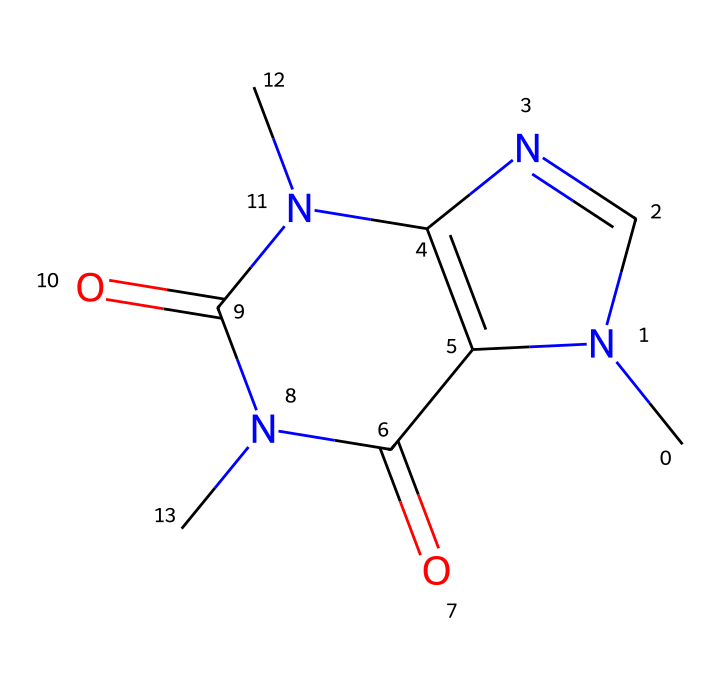What is the molecular formula of caffeine? By analyzing the provided SMILES representation, we can identify the individual atoms present in the chemical structure. The structure contains 8 carbon (C), 10 hydrogen (H), 4 nitrogen (N), and 2 oxygen (O) atoms. Thus, the molecular formula can be compiled as C8H10N4O2.
Answer: C8H10N4O2 How many nitrogen atoms are in caffeine? From the SMILES notation, we can count the number of nitrogen (N) atoms in the structure. The structure shows four distinct nitrogen atoms present.
Answer: 4 What functional groups are present in caffeine? The SMILES representation indicates the presence of carbonyl groups (C=O) and amino groups (N). Caffeine has two carbonyl groups and several nitrogen atoms that are characteristic of amino groups, confirming its classification as an amide.
Answer: carbonyl and amino What is the general classification of caffeine? Considering that caffeine is composed of various carbon, hydrogen, nitrogen, and oxygen, we should classify it based on its chemical behavior. Caffeine is typically characterized as an alkaloid due to its derived properties and nitrogen presence, and it also behaves as a non-electrolyte in solution.
Answer: alkaloid What type of bonds are primarily present in caffeine? Reviewing the SMILES representation allows us to see that caffeine contains primarily covalent bonds between the carbon, nitrogen, and oxygen atoms. This assertion is supported by the nature of atoms involved, as they share electrons with one another to form stable structures.
Answer: covalent How does caffeine affect the central nervous system? Caffeine acts as a stimulant by blocking adenosine receptors in the brain, which prevents the calming effects of adenosine and promotes alertness. This is because of its structure, which allows it to fit into these receptors.
Answer: stimulant 